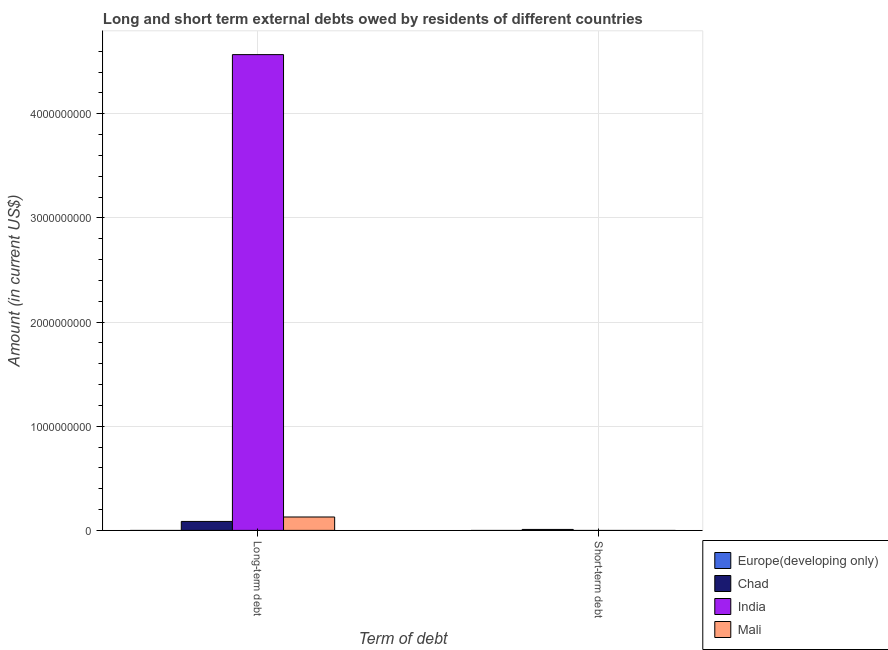How many bars are there on the 1st tick from the left?
Offer a very short reply. 3. How many bars are there on the 2nd tick from the right?
Offer a very short reply. 3. What is the label of the 2nd group of bars from the left?
Provide a short and direct response. Short-term debt. What is the short-term debts owed by residents in Mali?
Give a very brief answer. 0. Across all countries, what is the maximum long-term debts owed by residents?
Make the answer very short. 4.57e+09. In which country was the short-term debts owed by residents maximum?
Make the answer very short. Chad. What is the total long-term debts owed by residents in the graph?
Offer a very short reply. 4.78e+09. What is the difference between the long-term debts owed by residents in Mali and that in India?
Your answer should be very brief. -4.44e+09. What is the difference between the long-term debts owed by residents in India and the short-term debts owed by residents in Europe(developing only)?
Offer a terse response. 4.57e+09. What is the average long-term debts owed by residents per country?
Offer a very short reply. 1.20e+09. What is the difference between the long-term debts owed by residents and short-term debts owed by residents in Chad?
Ensure brevity in your answer.  7.68e+07. In how many countries, is the short-term debts owed by residents greater than 4200000000 US$?
Give a very brief answer. 0. What is the ratio of the long-term debts owed by residents in Chad to that in India?
Keep it short and to the point. 0.02. Is the long-term debts owed by residents in Chad less than that in Mali?
Your answer should be compact. Yes. In how many countries, is the long-term debts owed by residents greater than the average long-term debts owed by residents taken over all countries?
Keep it short and to the point. 1. How many bars are there?
Offer a very short reply. 4. Are all the bars in the graph horizontal?
Make the answer very short. No. How many countries are there in the graph?
Your answer should be compact. 4. What is the difference between two consecutive major ticks on the Y-axis?
Offer a terse response. 1.00e+09. Does the graph contain grids?
Your answer should be very brief. Yes. What is the title of the graph?
Provide a succinct answer. Long and short term external debts owed by residents of different countries. What is the label or title of the X-axis?
Keep it short and to the point. Term of debt. What is the Amount (in current US$) in Chad in Long-term debt?
Ensure brevity in your answer.  8.59e+07. What is the Amount (in current US$) of India in Long-term debt?
Provide a succinct answer. 4.57e+09. What is the Amount (in current US$) of Mali in Long-term debt?
Provide a short and direct response. 1.28e+08. What is the Amount (in current US$) in Europe(developing only) in Short-term debt?
Your answer should be compact. 0. What is the Amount (in current US$) in Chad in Short-term debt?
Give a very brief answer. 9.16e+06. What is the Amount (in current US$) of India in Short-term debt?
Your answer should be compact. 0. Across all Term of debt, what is the maximum Amount (in current US$) in Chad?
Make the answer very short. 8.59e+07. Across all Term of debt, what is the maximum Amount (in current US$) in India?
Provide a short and direct response. 4.57e+09. Across all Term of debt, what is the maximum Amount (in current US$) in Mali?
Provide a succinct answer. 1.28e+08. Across all Term of debt, what is the minimum Amount (in current US$) of Chad?
Your answer should be compact. 9.16e+06. Across all Term of debt, what is the minimum Amount (in current US$) of India?
Your answer should be very brief. 0. What is the total Amount (in current US$) of Chad in the graph?
Give a very brief answer. 9.51e+07. What is the total Amount (in current US$) in India in the graph?
Ensure brevity in your answer.  4.57e+09. What is the total Amount (in current US$) in Mali in the graph?
Provide a short and direct response. 1.28e+08. What is the difference between the Amount (in current US$) of Chad in Long-term debt and that in Short-term debt?
Offer a terse response. 7.68e+07. What is the average Amount (in current US$) in Europe(developing only) per Term of debt?
Your answer should be compact. 0. What is the average Amount (in current US$) in Chad per Term of debt?
Your answer should be very brief. 4.76e+07. What is the average Amount (in current US$) of India per Term of debt?
Your response must be concise. 2.28e+09. What is the average Amount (in current US$) of Mali per Term of debt?
Ensure brevity in your answer.  6.42e+07. What is the difference between the Amount (in current US$) of Chad and Amount (in current US$) of India in Long-term debt?
Your answer should be compact. -4.48e+09. What is the difference between the Amount (in current US$) of Chad and Amount (in current US$) of Mali in Long-term debt?
Your answer should be compact. -4.25e+07. What is the difference between the Amount (in current US$) in India and Amount (in current US$) in Mali in Long-term debt?
Give a very brief answer. 4.44e+09. What is the ratio of the Amount (in current US$) of Chad in Long-term debt to that in Short-term debt?
Offer a very short reply. 9.38. What is the difference between the highest and the second highest Amount (in current US$) in Chad?
Your response must be concise. 7.68e+07. What is the difference between the highest and the lowest Amount (in current US$) in Chad?
Offer a terse response. 7.68e+07. What is the difference between the highest and the lowest Amount (in current US$) in India?
Make the answer very short. 4.57e+09. What is the difference between the highest and the lowest Amount (in current US$) of Mali?
Offer a terse response. 1.28e+08. 